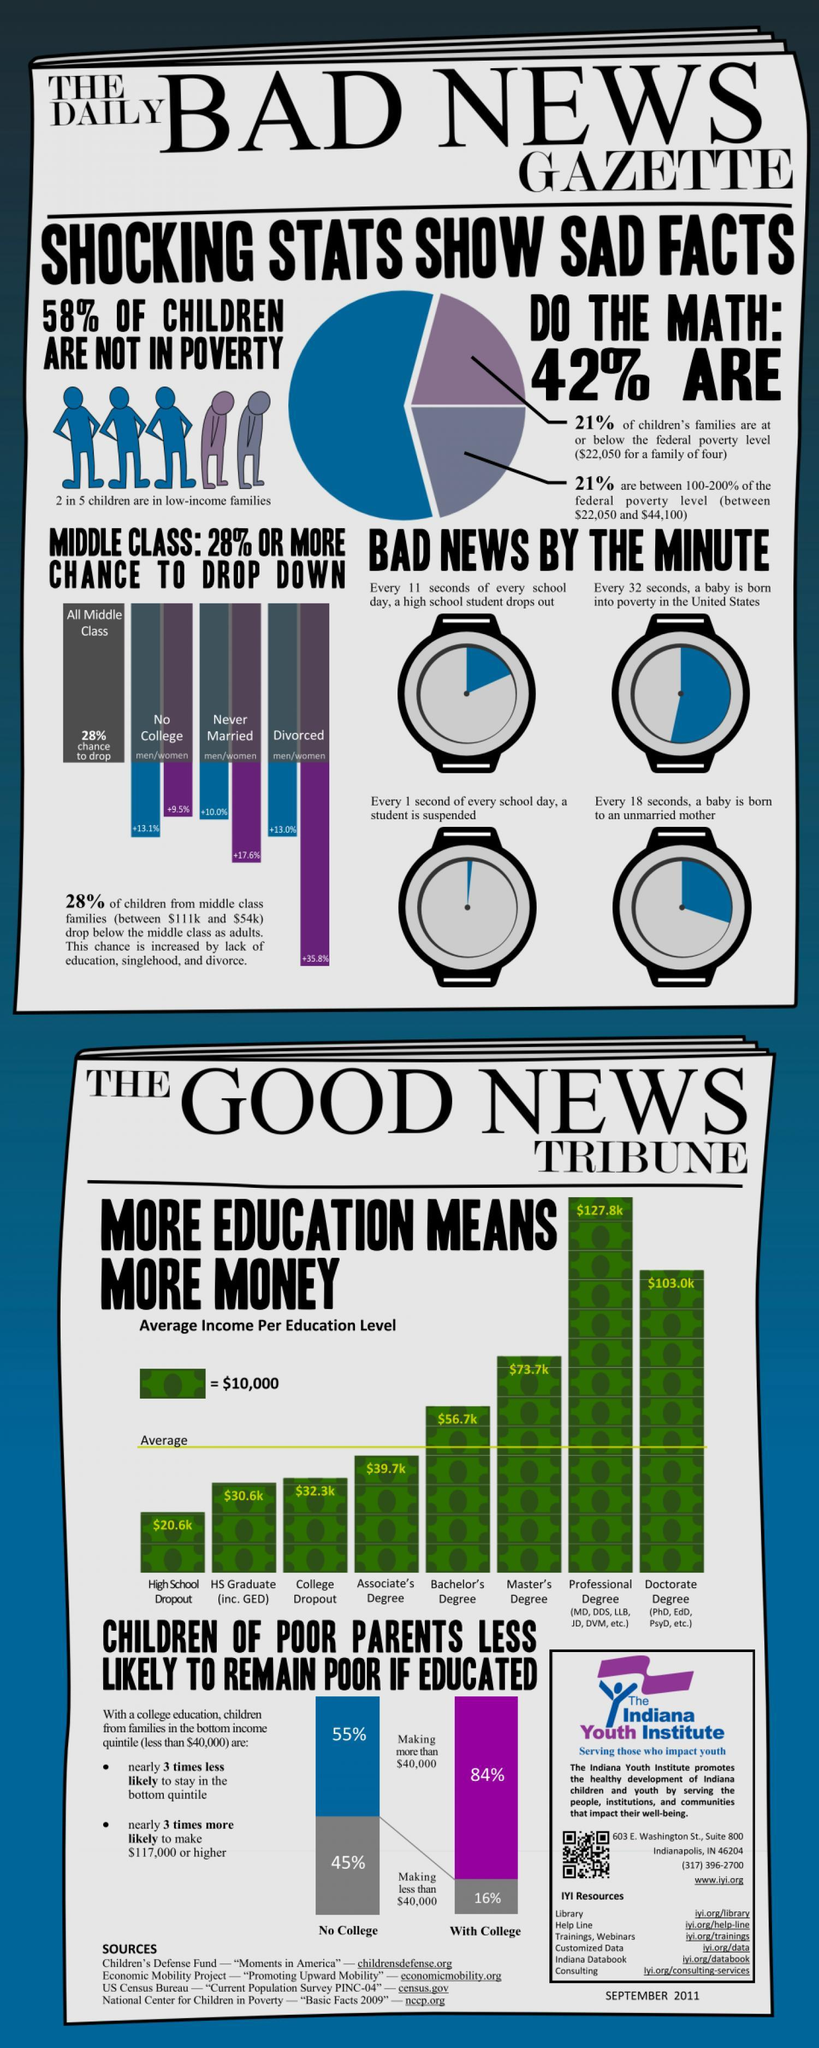In a minute, how frequently is a child suspended from school due to poverty, every second, every 18 secs, every 32 secs, or  every 11 secs?
Answer the question with a short phrase. every second What is difference in income of person with Professional and Master's degree? $54.1k Which category of education helps in earning the highest income? Professional degree What percentage of people with a college degree are more likely to earn an income below $40,000? 16% Who has a higher chance of dropping into poverty, uneducated women, unmarried women, or divorced women? divorced women What is the highest percentage of men dropping into poverty? +13.1% 